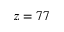<formula> <loc_0><loc_0><loc_500><loc_500>z = 7 7</formula> 